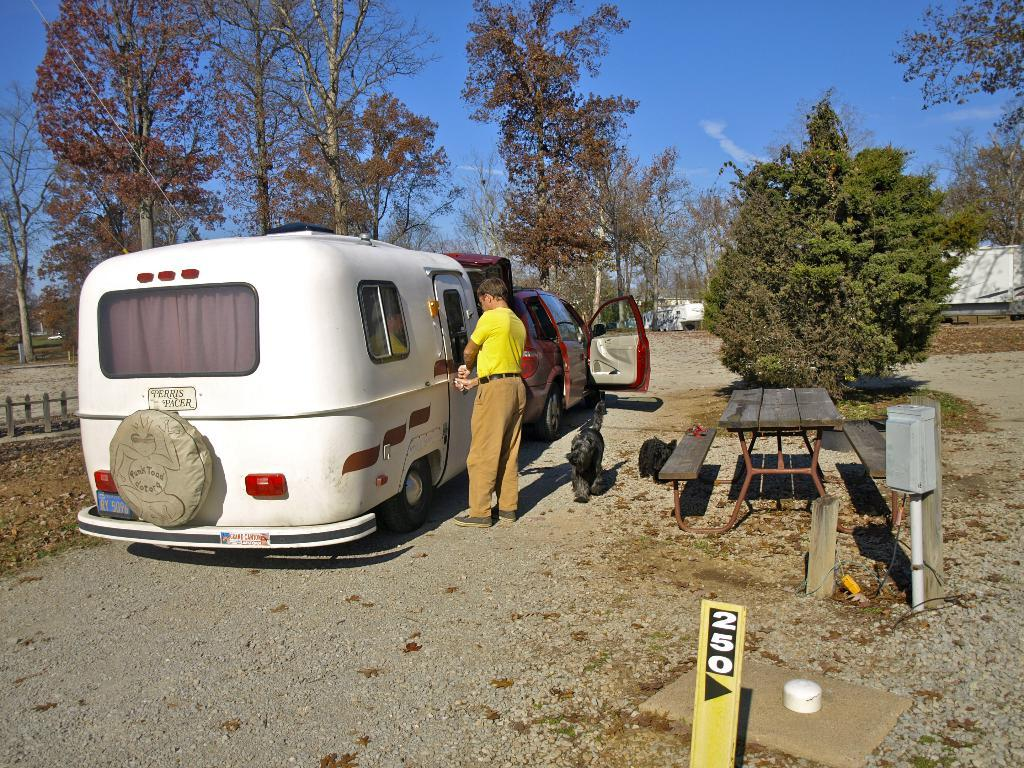What is the man in the image standing next to? The man is standing next to a white vehicle. Can you describe the other vehicle in the image? There is another vehicle in the image, but its description is not provided in the facts. What type of natural scenery can be seen in the image? Trees are visible in the image. How is the sky depicted in the image? The sky is visible and has a clear view. What type of chalk is being used to draw on the white vehicle in the image? There is no chalk or drawing present on the white vehicle in the image. How does the man in the image provide support to the trees? The man is not shown providing support to the trees in the image. 